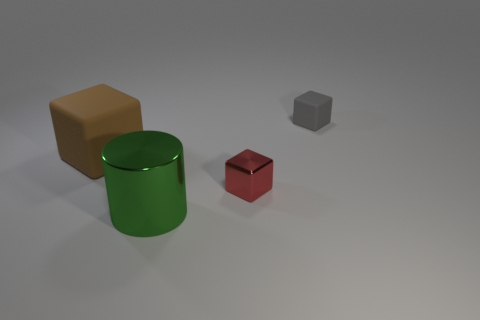How many objects are there in the image and can you describe their shapes and colors? There are four objects in the image. Starting from the largest, there is a brown block that appears to have a cube-like structure, a green cylindrical object, a smaller red cube, and an even smaller grey object that has the shape of a smaller cube. 